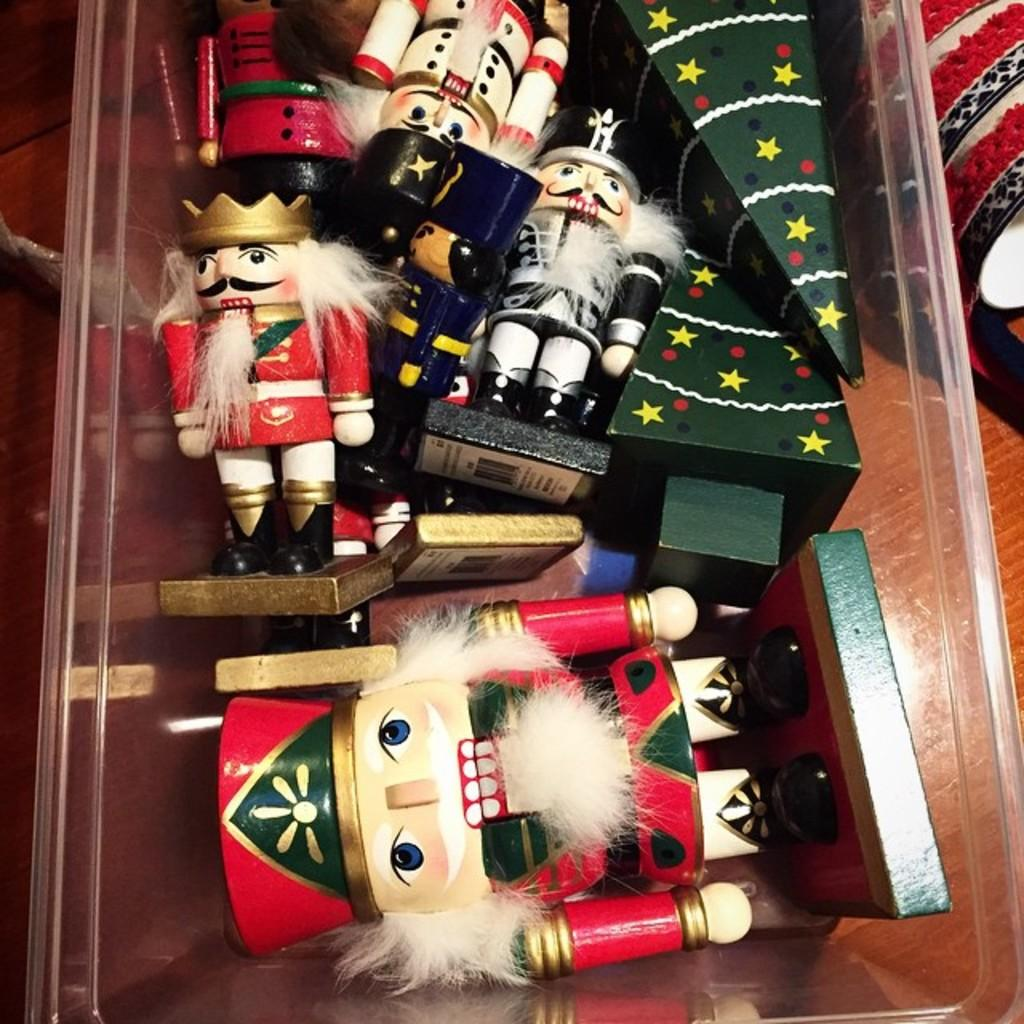What is inside the box that is visible in the image? There are toys in a box in the image. Where is the box located? The box is placed on a wooden table. What else can be seen on the wooden table? There is an object on the wooden table. What type of division is taking place between the toys in the image? There is no division taking place between the toys in the image; they are all contained within the box. 